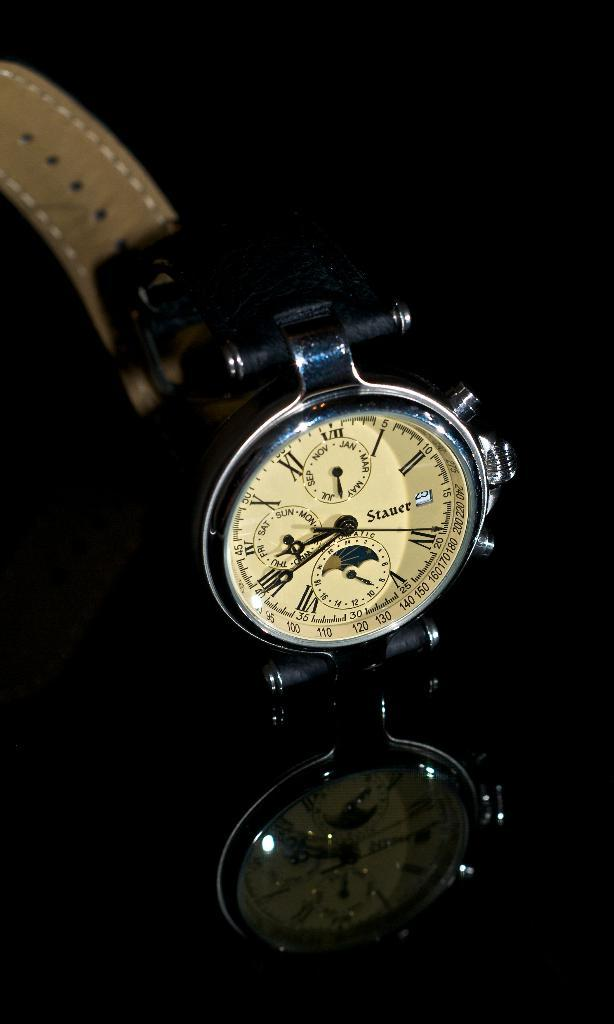<image>
Give a short and clear explanation of the subsequent image. a old fashion stauer watch with the moon 